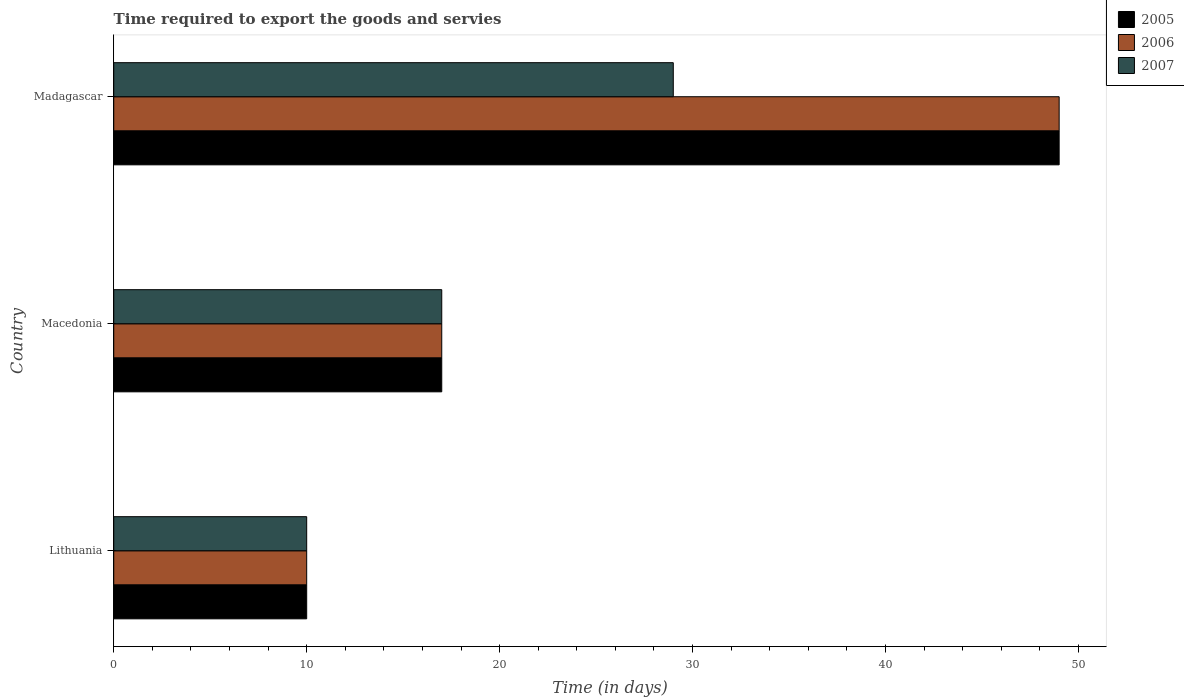How many groups of bars are there?
Keep it short and to the point. 3. Are the number of bars per tick equal to the number of legend labels?
Your answer should be very brief. Yes. Are the number of bars on each tick of the Y-axis equal?
Keep it short and to the point. Yes. How many bars are there on the 1st tick from the top?
Ensure brevity in your answer.  3. How many bars are there on the 1st tick from the bottom?
Offer a terse response. 3. What is the label of the 3rd group of bars from the top?
Your response must be concise. Lithuania. In how many cases, is the number of bars for a given country not equal to the number of legend labels?
Keep it short and to the point. 0. In which country was the number of days required to export the goods and services in 2006 maximum?
Your answer should be very brief. Madagascar. In which country was the number of days required to export the goods and services in 2007 minimum?
Offer a terse response. Lithuania. What is the total number of days required to export the goods and services in 2006 in the graph?
Ensure brevity in your answer.  76. What is the difference between the number of days required to export the goods and services in 2005 in Macedonia and that in Madagascar?
Keep it short and to the point. -32. What is the difference between the number of days required to export the goods and services in 2007 in Lithuania and the number of days required to export the goods and services in 2005 in Madagascar?
Offer a terse response. -39. What is the average number of days required to export the goods and services in 2006 per country?
Offer a very short reply. 25.33. What is the difference between the number of days required to export the goods and services in 2005 and number of days required to export the goods and services in 2007 in Macedonia?
Make the answer very short. 0. In how many countries, is the number of days required to export the goods and services in 2006 greater than 8 days?
Offer a very short reply. 3. What is the ratio of the number of days required to export the goods and services in 2007 in Macedonia to that in Madagascar?
Offer a very short reply. 0.59. Is the number of days required to export the goods and services in 2006 in Lithuania less than that in Macedonia?
Provide a succinct answer. Yes. What is the difference between the highest and the second highest number of days required to export the goods and services in 2006?
Your answer should be compact. 32. What is the difference between the highest and the lowest number of days required to export the goods and services in 2007?
Your answer should be compact. 19. In how many countries, is the number of days required to export the goods and services in 2007 greater than the average number of days required to export the goods and services in 2007 taken over all countries?
Your answer should be very brief. 1. Is the sum of the number of days required to export the goods and services in 2007 in Macedonia and Madagascar greater than the maximum number of days required to export the goods and services in 2006 across all countries?
Make the answer very short. No. What does the 2nd bar from the top in Madagascar represents?
Offer a terse response. 2006. What does the 3rd bar from the bottom in Madagascar represents?
Offer a very short reply. 2007. Is it the case that in every country, the sum of the number of days required to export the goods and services in 2007 and number of days required to export the goods and services in 2005 is greater than the number of days required to export the goods and services in 2006?
Provide a succinct answer. Yes. Does the graph contain any zero values?
Offer a very short reply. No. Does the graph contain grids?
Your response must be concise. No. Where does the legend appear in the graph?
Offer a very short reply. Top right. What is the title of the graph?
Your answer should be very brief. Time required to export the goods and servies. Does "1977" appear as one of the legend labels in the graph?
Offer a terse response. No. What is the label or title of the X-axis?
Make the answer very short. Time (in days). What is the label or title of the Y-axis?
Your answer should be compact. Country. What is the Time (in days) of 2005 in Lithuania?
Ensure brevity in your answer.  10. What is the Time (in days) in 2006 in Lithuania?
Keep it short and to the point. 10. What is the Time (in days) in 2007 in Lithuania?
Offer a terse response. 10. What is the Time (in days) of 2006 in Macedonia?
Your answer should be compact. 17. What is the Time (in days) of 2005 in Madagascar?
Provide a succinct answer. 49. What is the Time (in days) in 2006 in Madagascar?
Your answer should be compact. 49. What is the Time (in days) in 2007 in Madagascar?
Ensure brevity in your answer.  29. Across all countries, what is the maximum Time (in days) of 2005?
Give a very brief answer. 49. Across all countries, what is the maximum Time (in days) in 2007?
Provide a short and direct response. 29. Across all countries, what is the minimum Time (in days) of 2006?
Your answer should be very brief. 10. What is the total Time (in days) in 2005 in the graph?
Ensure brevity in your answer.  76. What is the difference between the Time (in days) of 2005 in Lithuania and that in Macedonia?
Offer a terse response. -7. What is the difference between the Time (in days) in 2005 in Lithuania and that in Madagascar?
Offer a very short reply. -39. What is the difference between the Time (in days) in 2006 in Lithuania and that in Madagascar?
Offer a terse response. -39. What is the difference between the Time (in days) in 2007 in Lithuania and that in Madagascar?
Offer a terse response. -19. What is the difference between the Time (in days) in 2005 in Macedonia and that in Madagascar?
Your answer should be very brief. -32. What is the difference between the Time (in days) in 2006 in Macedonia and that in Madagascar?
Your answer should be very brief. -32. What is the difference between the Time (in days) of 2007 in Macedonia and that in Madagascar?
Your answer should be very brief. -12. What is the difference between the Time (in days) in 2005 in Lithuania and the Time (in days) in 2006 in Macedonia?
Your response must be concise. -7. What is the difference between the Time (in days) of 2006 in Lithuania and the Time (in days) of 2007 in Macedonia?
Your answer should be compact. -7. What is the difference between the Time (in days) of 2005 in Lithuania and the Time (in days) of 2006 in Madagascar?
Your answer should be compact. -39. What is the difference between the Time (in days) in 2005 in Lithuania and the Time (in days) in 2007 in Madagascar?
Provide a succinct answer. -19. What is the difference between the Time (in days) of 2006 in Lithuania and the Time (in days) of 2007 in Madagascar?
Ensure brevity in your answer.  -19. What is the difference between the Time (in days) of 2005 in Macedonia and the Time (in days) of 2006 in Madagascar?
Keep it short and to the point. -32. What is the difference between the Time (in days) in 2005 in Macedonia and the Time (in days) in 2007 in Madagascar?
Provide a succinct answer. -12. What is the average Time (in days) of 2005 per country?
Provide a succinct answer. 25.33. What is the average Time (in days) of 2006 per country?
Offer a terse response. 25.33. What is the average Time (in days) in 2007 per country?
Provide a short and direct response. 18.67. What is the difference between the Time (in days) in 2005 and Time (in days) in 2006 in Lithuania?
Offer a very short reply. 0. What is the difference between the Time (in days) in 2005 and Time (in days) in 2007 in Lithuania?
Give a very brief answer. 0. What is the difference between the Time (in days) of 2005 and Time (in days) of 2006 in Macedonia?
Keep it short and to the point. 0. What is the difference between the Time (in days) of 2006 and Time (in days) of 2007 in Macedonia?
Keep it short and to the point. 0. What is the difference between the Time (in days) of 2005 and Time (in days) of 2006 in Madagascar?
Provide a short and direct response. 0. What is the ratio of the Time (in days) in 2005 in Lithuania to that in Macedonia?
Offer a terse response. 0.59. What is the ratio of the Time (in days) in 2006 in Lithuania to that in Macedonia?
Give a very brief answer. 0.59. What is the ratio of the Time (in days) in 2007 in Lithuania to that in Macedonia?
Offer a terse response. 0.59. What is the ratio of the Time (in days) of 2005 in Lithuania to that in Madagascar?
Offer a very short reply. 0.2. What is the ratio of the Time (in days) of 2006 in Lithuania to that in Madagascar?
Your response must be concise. 0.2. What is the ratio of the Time (in days) in 2007 in Lithuania to that in Madagascar?
Your answer should be very brief. 0.34. What is the ratio of the Time (in days) in 2005 in Macedonia to that in Madagascar?
Provide a succinct answer. 0.35. What is the ratio of the Time (in days) of 2006 in Macedonia to that in Madagascar?
Provide a succinct answer. 0.35. What is the ratio of the Time (in days) of 2007 in Macedonia to that in Madagascar?
Provide a short and direct response. 0.59. What is the difference between the highest and the second highest Time (in days) of 2005?
Provide a short and direct response. 32. What is the difference between the highest and the lowest Time (in days) in 2006?
Offer a terse response. 39. 